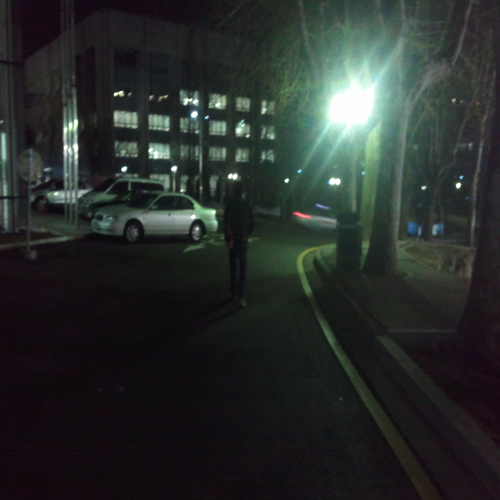Is the overall clarity of the image low?
A. Yes
B. No
Answer with the option's letter from the given choices directly.
 A. 